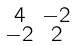<formula> <loc_0><loc_0><loc_500><loc_500>\begin{smallmatrix} 4 & - 2 \\ - 2 & 2 \end{smallmatrix}</formula> 